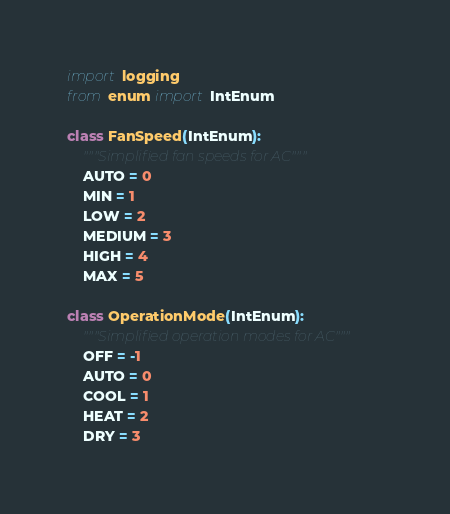<code> <loc_0><loc_0><loc_500><loc_500><_Python_>import logging
from enum import IntEnum

class FanSpeed(IntEnum):
    """Simplified fan speeds for AC"""
    AUTO = 0
    MIN = 1
    LOW = 2
    MEDIUM = 3
    HIGH = 4
    MAX = 5

class OperationMode(IntEnum):
    """Simplified operation modes for AC"""
    OFF = -1
    AUTO = 0
    COOL = 1
    HEAT = 2
    DRY = 3</code> 